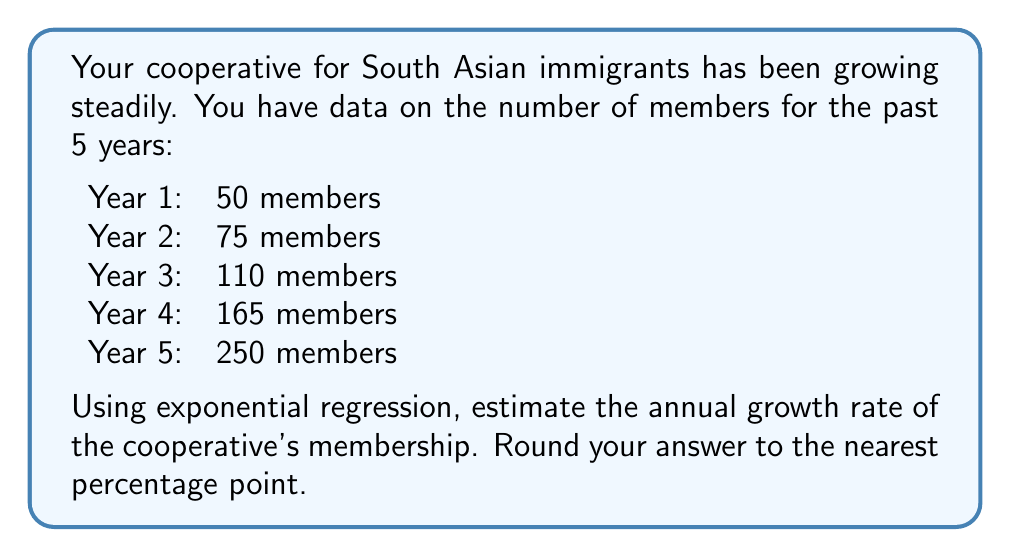Help me with this question. To estimate the growth rate using exponential regression, we'll follow these steps:

1) The exponential growth model is given by $y = a(1+r)^t$, where $y$ is the number of members, $a$ is the initial number, $r$ is the growth rate, and $t$ is the time in years.

2) Taking logarithms of both sides: $\ln(y) = \ln(a) + t\ln(1+r)$

3) This is now in the form of a linear equation: $Y = b + mX$, where:
   $Y = \ln(y)$, $X = t$, $b = \ln(a)$, and $m = \ln(1+r)$

4) We'll use the given data to calculate $\sum X$, $\sum Y$, $\sum XY$, and $\sum X^2$:

   $\sum X = 0 + 1 + 2 + 3 + 4 = 10$
   $\sum Y = \ln(50) + \ln(75) + \ln(110) + \ln(165) + \ln(250) = 25.8349$
   $\sum XY = 0\ln(50) + 1\ln(75) + 2\ln(110) + 3\ln(165) + 4\ln(250) = 71.7047$
   $\sum X^2 = 0^2 + 1^2 + 2^2 + 3^2 + 4^2 = 30$

5) Using the formula for the slope in linear regression:

   $m = \frac{n\sum XY - \sum X \sum Y}{n\sum X^2 - (\sum X)^2}$

   $m = \frac{5(71.7047) - 10(25.8349)}{5(30) - 10^2} = 0.4055$

6) Since $m = \ln(1+r)$, we can find $r$:

   $r = e^m - 1 = e^{0.4055} - 1 = 0.5000$

7) Converting to a percentage and rounding to the nearest point gives 50%.
Answer: 50% 